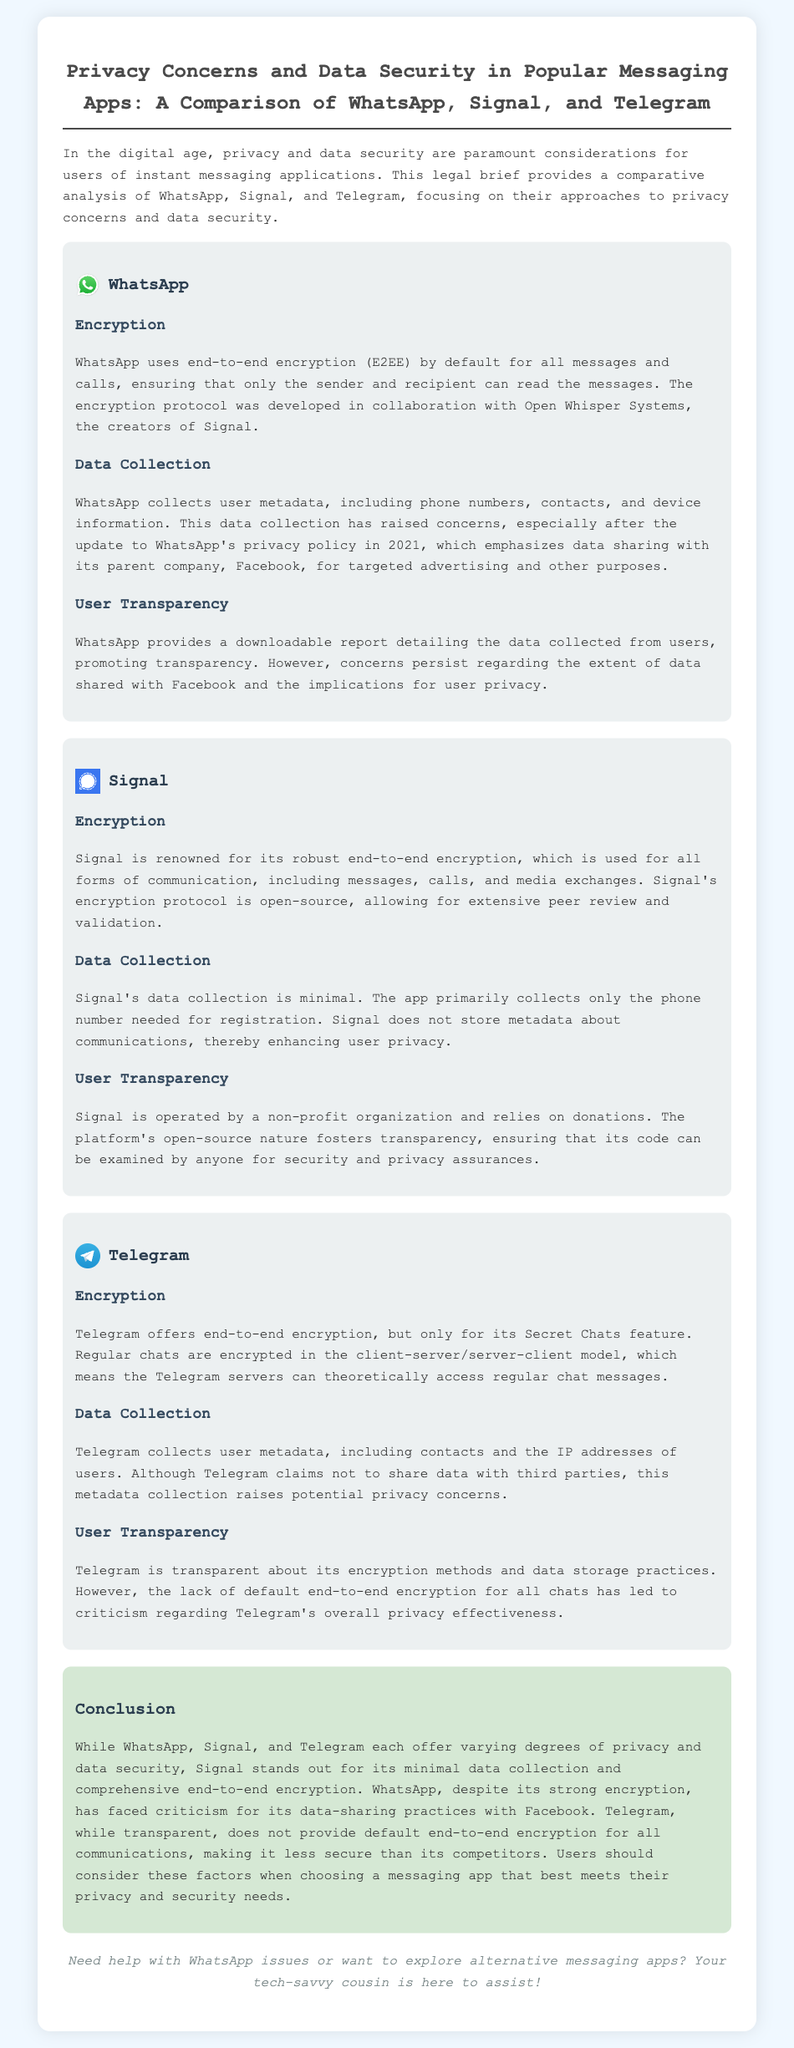What encryption protocol does WhatsApp use? WhatsApp uses end-to-end encryption (E2EE) by default for all messages and calls, developed in collaboration with Open Whisper Systems.
Answer: end-to-end encryption (E2EE) What organization operates Signal? Signal is operated by a non-profit organization, which relies on donations for its operation.
Answer: non-profit organization What feature of Telegram offers end-to-end encryption? Telegram offers end-to-end encryption, but only for its Secret Chats feature.
Answer: Secret Chats What type of metadata does WhatsApp collect? WhatsApp collects user metadata, including phone numbers, contacts, and device information.
Answer: phone numbers, contacts, device information Which messaging app has minimal data collection? Signal's data collection is minimal, primarily only collecting the phone number needed for registration.
Answer: Signal How does Telegram handle regular chats regarding encryption? Regular chats on Telegram are encrypted in the client-server/server-client model, allowing access to Telegram servers.
Answer: client-server/server-client model What data does Telegram claim not to share? Telegram claims not to share user data with third parties.
Answer: user data Which app is criticized for data-sharing practices with Facebook? WhatsApp has faced criticism for its data-sharing practices with Facebook.
Answer: WhatsApp What is a notable aspect of Signal’s encryption? Signal's encryption protocol is open-source, allowing for extensive peer review and validation.
Answer: open-source 